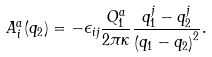<formula> <loc_0><loc_0><loc_500><loc_500>A _ { i } ^ { a } ( { q } _ { 2 } ) = - \epsilon _ { i j } \frac { Q _ { 1 } ^ { a } } { 2 \pi \kappa } \frac { q _ { 1 } ^ { j } - q _ { 2 } ^ { j } } { \left ( { q } _ { 1 } - { q } _ { 2 } \right ) ^ { 2 } } .</formula> 